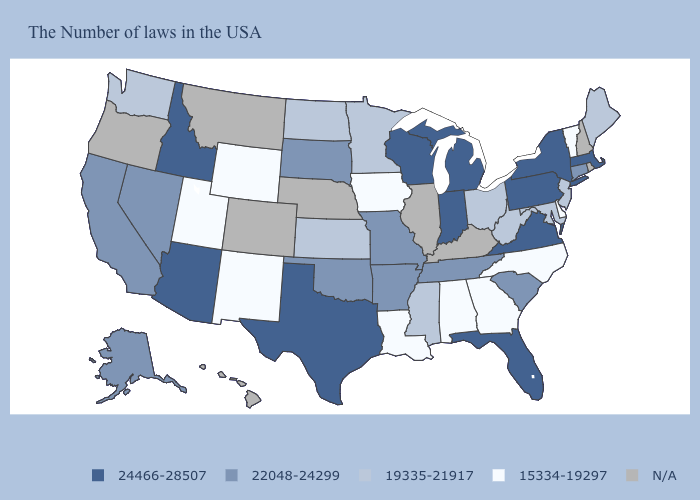Is the legend a continuous bar?
Keep it brief. No. Name the states that have a value in the range N/A?
Answer briefly. Rhode Island, New Hampshire, Kentucky, Illinois, Nebraska, Colorado, Montana, Oregon, Hawaii. Among the states that border North Carolina , does Georgia have the lowest value?
Quick response, please. Yes. Does the first symbol in the legend represent the smallest category?
Keep it brief. No. How many symbols are there in the legend?
Keep it brief. 5. What is the highest value in the USA?
Concise answer only. 24466-28507. Name the states that have a value in the range 19335-21917?
Quick response, please. Maine, New Jersey, Maryland, West Virginia, Ohio, Mississippi, Minnesota, Kansas, North Dakota, Washington. What is the value of Montana?
Give a very brief answer. N/A. What is the lowest value in the MidWest?
Keep it brief. 15334-19297. What is the value of Louisiana?
Answer briefly. 15334-19297. What is the value of Montana?
Keep it brief. N/A. What is the lowest value in the Northeast?
Quick response, please. 15334-19297. What is the value of West Virginia?
Short answer required. 19335-21917. Name the states that have a value in the range 19335-21917?
Answer briefly. Maine, New Jersey, Maryland, West Virginia, Ohio, Mississippi, Minnesota, Kansas, North Dakota, Washington. What is the value of Michigan?
Quick response, please. 24466-28507. 